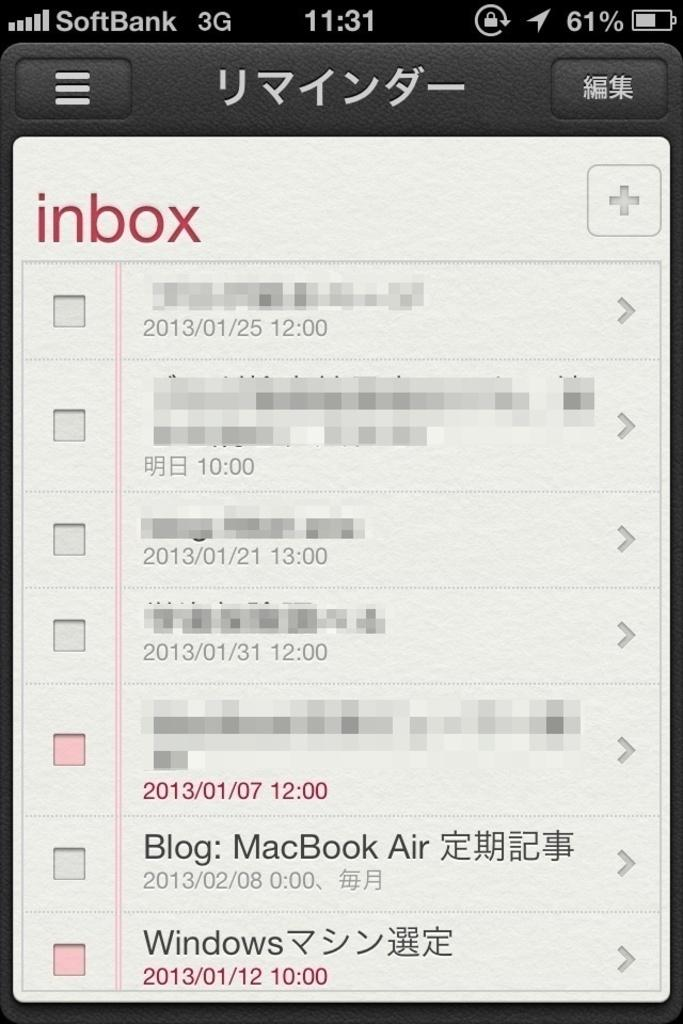<image>
Give a short and clear explanation of the subsequent image. An email inbox is displayed on a screen titled SoftBank 3G. 